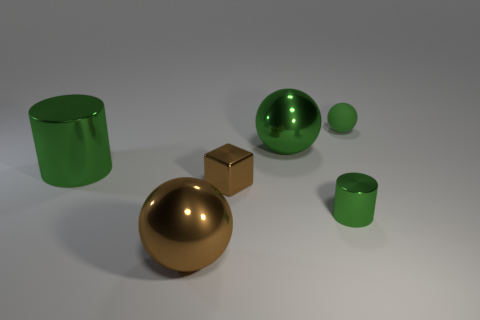Subtract all green cubes. How many green balls are left? 2 Add 2 brown blocks. How many objects exist? 8 Subtract all cylinders. How many objects are left? 4 Subtract all gray metal spheres. Subtract all large green metallic spheres. How many objects are left? 5 Add 3 tiny green matte balls. How many tiny green matte balls are left? 4 Add 2 green matte things. How many green matte things exist? 3 Subtract 0 brown cylinders. How many objects are left? 6 